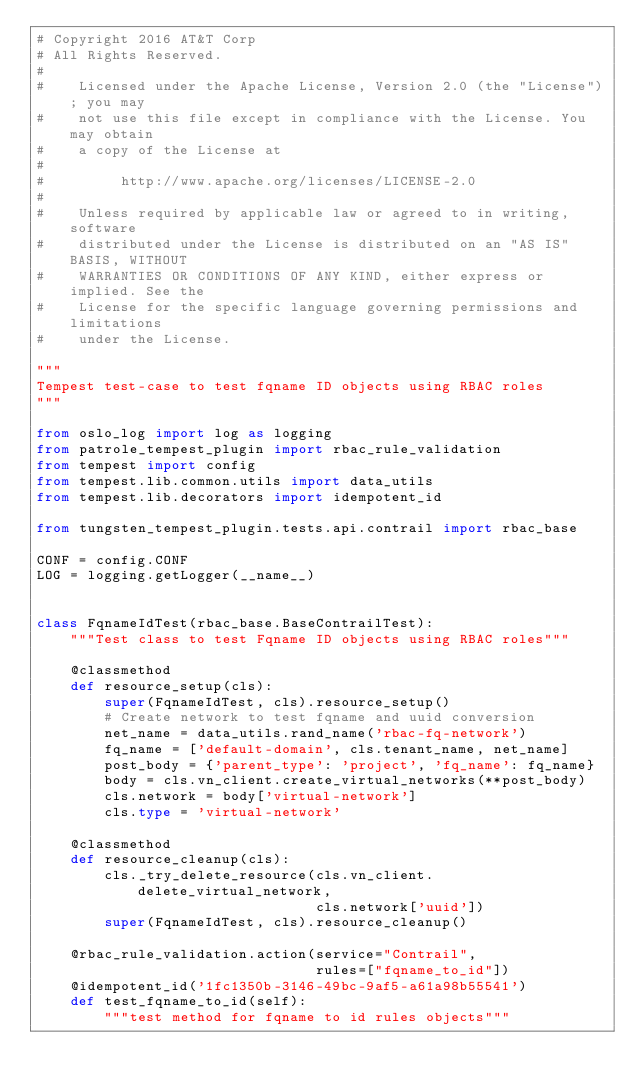<code> <loc_0><loc_0><loc_500><loc_500><_Python_># Copyright 2016 AT&T Corp
# All Rights Reserved.
#
#    Licensed under the Apache License, Version 2.0 (the "License"); you may
#    not use this file except in compliance with the License. You may obtain
#    a copy of the License at
#
#         http://www.apache.org/licenses/LICENSE-2.0
#
#    Unless required by applicable law or agreed to in writing, software
#    distributed under the License is distributed on an "AS IS" BASIS, WITHOUT
#    WARRANTIES OR CONDITIONS OF ANY KIND, either express or implied. See the
#    License for the specific language governing permissions and limitations
#    under the License.

"""
Tempest test-case to test fqname ID objects using RBAC roles
"""

from oslo_log import log as logging
from patrole_tempest_plugin import rbac_rule_validation
from tempest import config
from tempest.lib.common.utils import data_utils
from tempest.lib.decorators import idempotent_id

from tungsten_tempest_plugin.tests.api.contrail import rbac_base

CONF = config.CONF
LOG = logging.getLogger(__name__)


class FqnameIdTest(rbac_base.BaseContrailTest):
    """Test class to test Fqname ID objects using RBAC roles"""

    @classmethod
    def resource_setup(cls):
        super(FqnameIdTest, cls).resource_setup()
        # Create network to test fqname and uuid conversion
        net_name = data_utils.rand_name('rbac-fq-network')
        fq_name = ['default-domain', cls.tenant_name, net_name]
        post_body = {'parent_type': 'project', 'fq_name': fq_name}
        body = cls.vn_client.create_virtual_networks(**post_body)
        cls.network = body['virtual-network']
        cls.type = 'virtual-network'

    @classmethod
    def resource_cleanup(cls):
        cls._try_delete_resource(cls.vn_client.delete_virtual_network,
                                 cls.network['uuid'])
        super(FqnameIdTest, cls).resource_cleanup()

    @rbac_rule_validation.action(service="Contrail",
                                 rules=["fqname_to_id"])
    @idempotent_id('1fc1350b-3146-49bc-9af5-a61a98b55541')
    def test_fqname_to_id(self):
        """test method for fqname to id rules objects"""</code> 